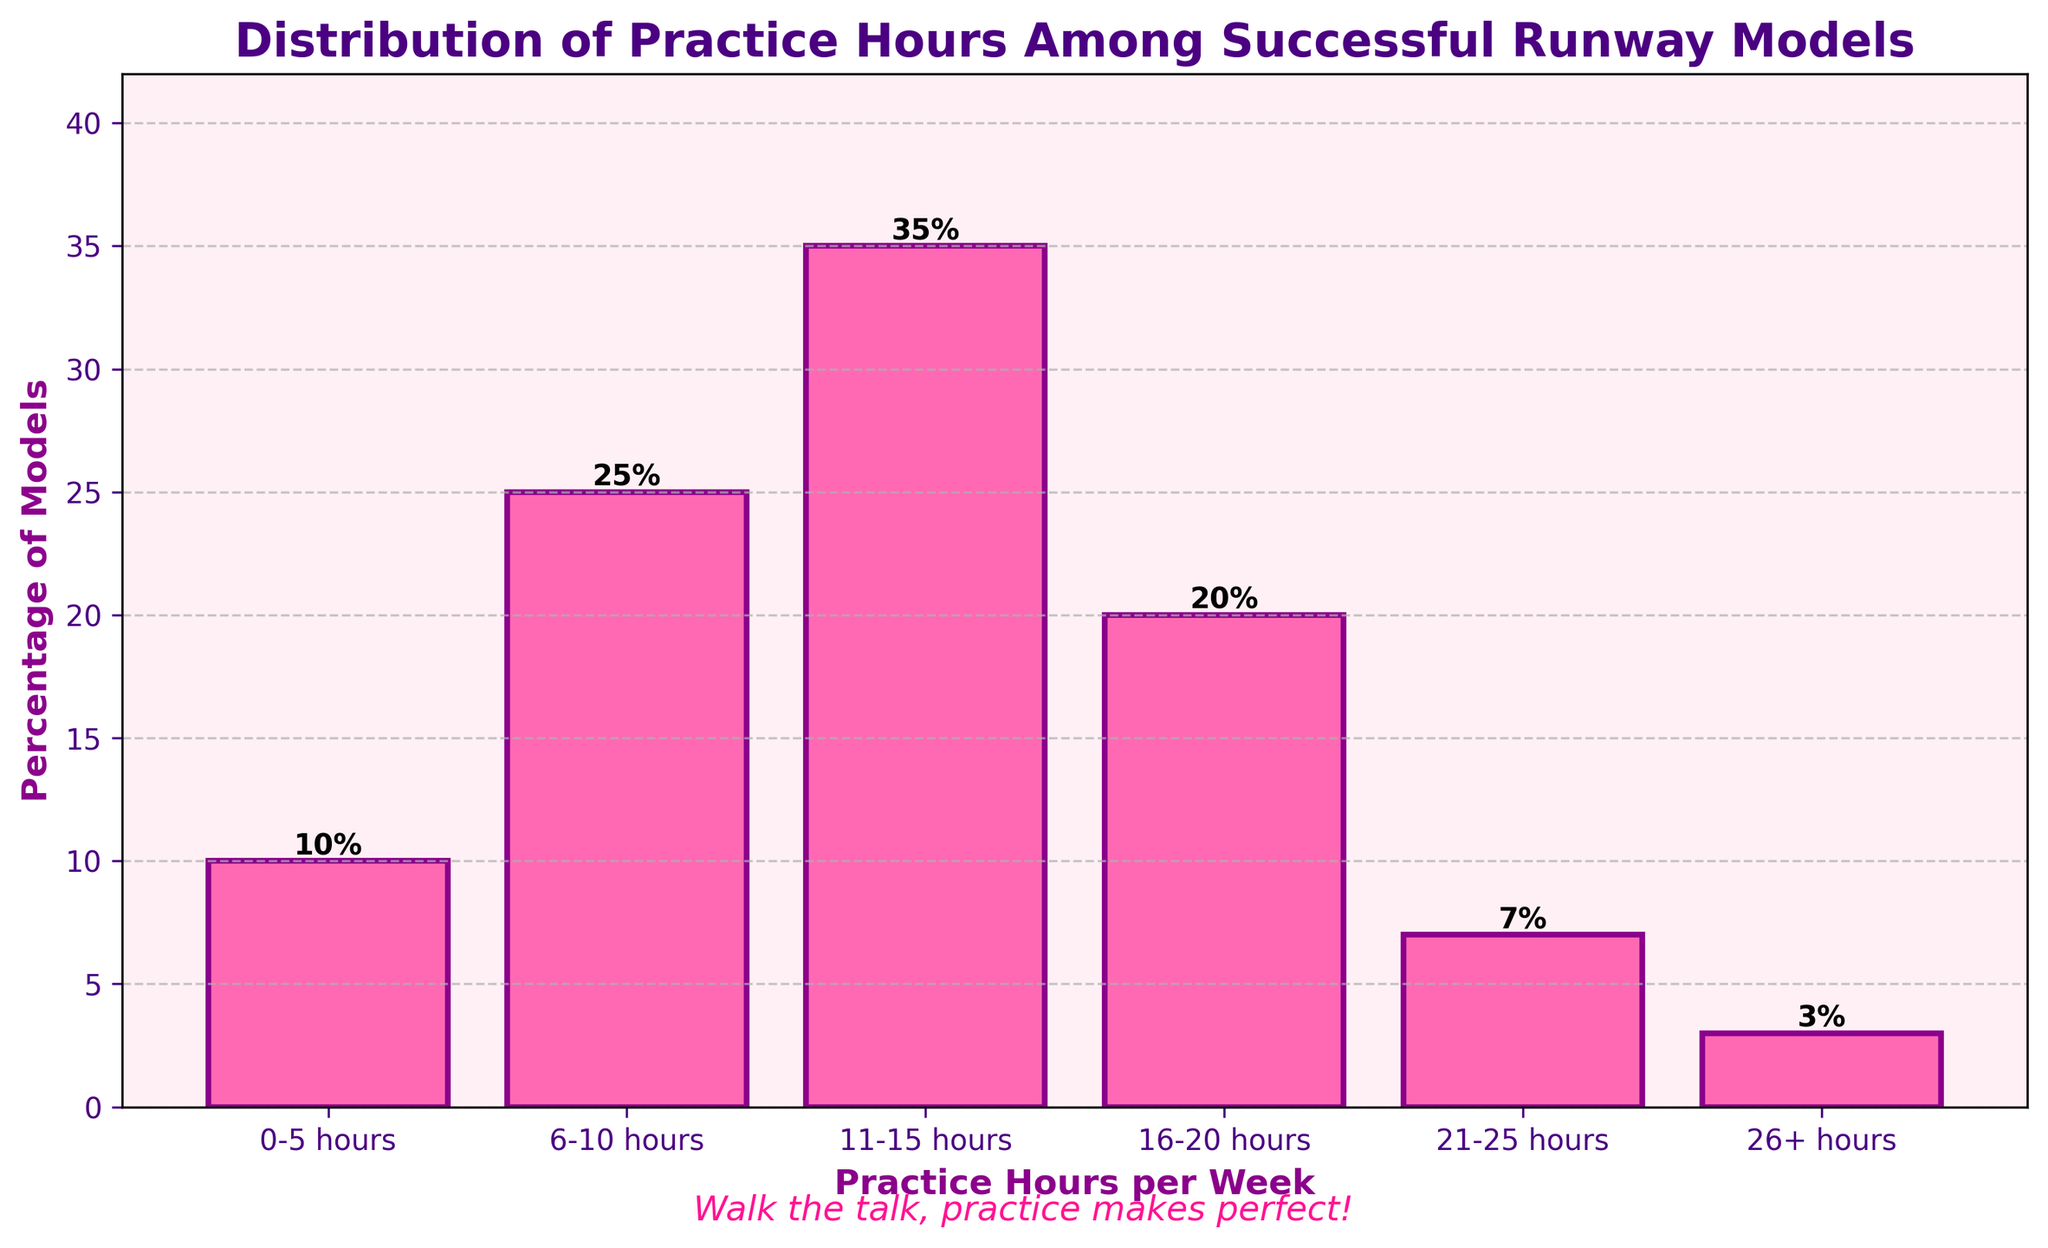What percentage of models practice between 11-15 hours per week? The bar corresponding to 11-15 hours shows a height of 35%. This indicates that 35% of models practice between 11-15 hours per week.
Answer: 35% Which practice hours category has the lowest percentage of models? The category '26+ hours' has the shortest bar, indicating the lowest percentage of models, which is 3%.
Answer: 26+ hours What is the total percentage of models that practice more than 10 hours per week? Adding the percentages for the categories '11-15 hours', '16-20 hours', '21-25 hours', and '26+ hours': 35% + 20% + 7% + 3% = 65%.
Answer: 65% How much higher is the percentage of models practicing 11-15 hours compared to those practicing 6-10 hours? The percentage for 11-15 hours is 35%, and for 6-10 hours, it is 25%. The difference is 35% - 25% = 10%.
Answer: 10% Which two practice hour categories together make up half of the total percentage of models? The categories 11-15 hours (35%) and 6-10 hours (25%) together make 35% + 25% = 60%, which is more than half. So consider the next best fit. The categories '11-15 hours' (35%) and '0-5 hours' (10%) make 35% + 10% = 45%, so combining 11-15 hours and 16-20 hours, 35% + 20% = 55%.
Answer: 11-15 hours and 6-10 hours Which practice hours category has a visually distinct pink color representation? All bars have a pink color, but the question refers to general color observation. All bars are visually consistent in pink.
Answer: All categories (not a distinct feature per this data set) How much greater is the percentage of models practicing 6-10 hours compared to those practicing 26+ hours? The percentage for 6-10 hours is 25%, and for 26+ hours, it is 3%. The difference is 25% - 3% = 22%.
Answer: 22% What is the median percentage of the practice hour categories? List the percentages in ascending order: 3%, 7%, 10%, 20%, 25%, 35%. Since there are 6 data points, the median is the average of the 3rd and 4th values, (10% + 20%)/2 = 15%.
Answer: 15% How does the grid on the y-axis assist in interpreting the chart? The grid lines help to easily read off the values from the y-axis by providing a visual reference to align with the tops of the bars, ensuring more accurate reading of the percentages.
Answer: Provides a visual reference for reading values accurately What is the combined percentage of models practicing either the least or the most hours? The least hours category is '26+ hours' with 3%, and the least hours (0-5 hours) category is 10%, combining these gives 3% + 10% = 13%.
Answer: 13% 